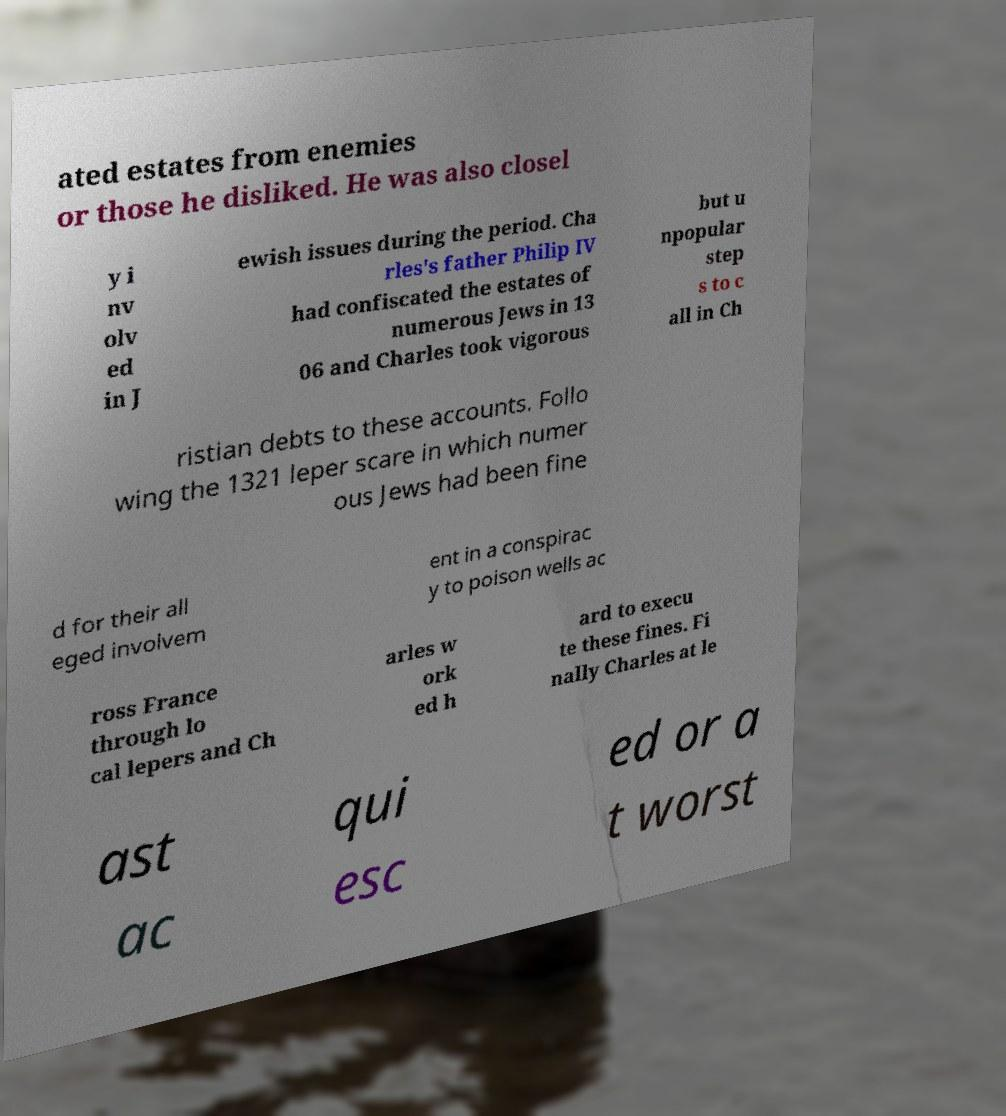Please read and relay the text visible in this image. What does it say? ated estates from enemies or those he disliked. He was also closel y i nv olv ed in J ewish issues during the period. Cha rles's father Philip IV had confiscated the estates of numerous Jews in 13 06 and Charles took vigorous but u npopular step s to c all in Ch ristian debts to these accounts. Follo wing the 1321 leper scare in which numer ous Jews had been fine d for their all eged involvem ent in a conspirac y to poison wells ac ross France through lo cal lepers and Ch arles w ork ed h ard to execu te these fines. Fi nally Charles at le ast ac qui esc ed or a t worst 